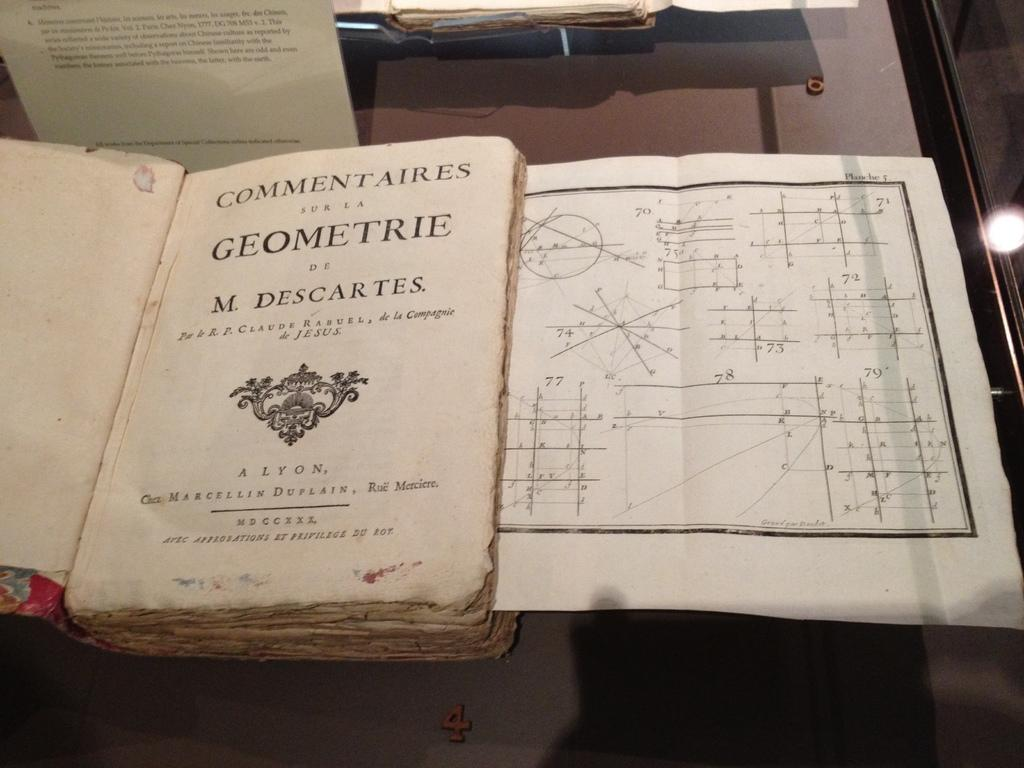What is the main object in the image? The image contains a book. Can you describe any additional elements in the image? There is a diagram in a chart on the right side of the image. What type of curtain is hanging on the left side of the image? There is no curtain present in the image; it only contains a book and a diagram in a chart. 